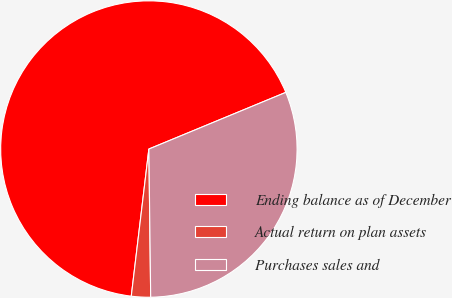Convert chart to OTSL. <chart><loc_0><loc_0><loc_500><loc_500><pie_chart><fcel>Ending balance as of December<fcel>Actual return on plan assets<fcel>Purchases sales and<nl><fcel>66.86%<fcel>2.09%<fcel>31.05%<nl></chart> 